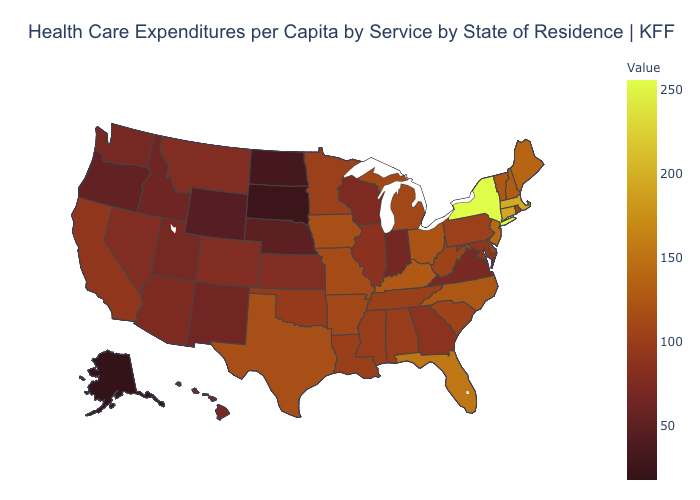Does the map have missing data?
Short answer required. No. Does Arizona have a lower value than West Virginia?
Be succinct. Yes. Which states have the lowest value in the MidWest?
Quick response, please. South Dakota. 